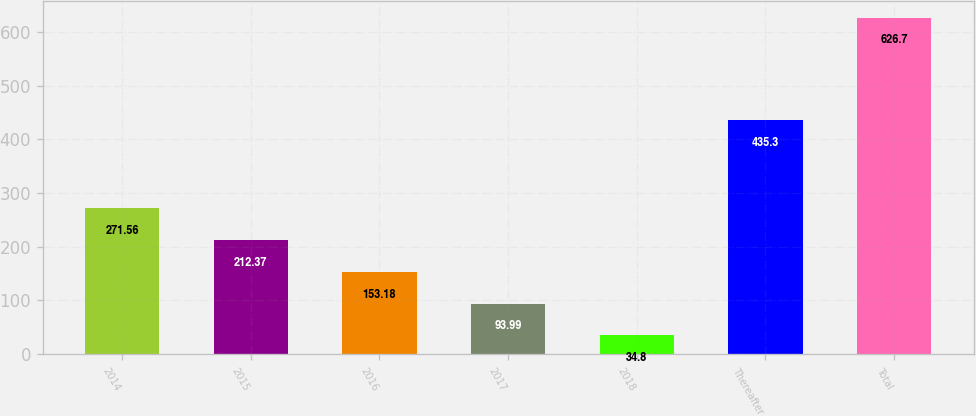<chart> <loc_0><loc_0><loc_500><loc_500><bar_chart><fcel>2014<fcel>2015<fcel>2016<fcel>2017<fcel>2018<fcel>Thereafter<fcel>Total<nl><fcel>271.56<fcel>212.37<fcel>153.18<fcel>93.99<fcel>34.8<fcel>435.3<fcel>626.7<nl></chart> 